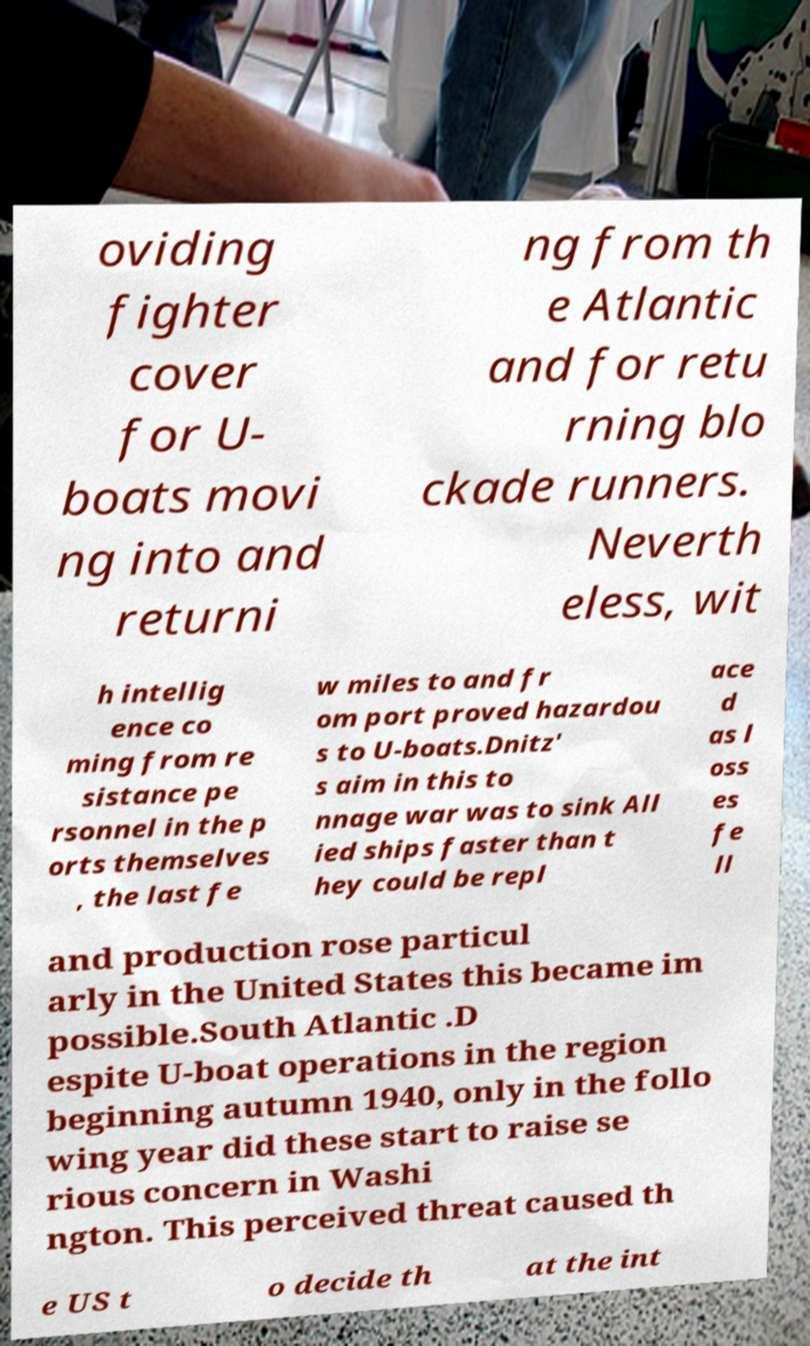Can you read and provide the text displayed in the image?This photo seems to have some interesting text. Can you extract and type it out for me? oviding fighter cover for U- boats movi ng into and returni ng from th e Atlantic and for retu rning blo ckade runners. Neverth eless, wit h intellig ence co ming from re sistance pe rsonnel in the p orts themselves , the last fe w miles to and fr om port proved hazardou s to U-boats.Dnitz' s aim in this to nnage war was to sink All ied ships faster than t hey could be repl ace d as l oss es fe ll and production rose particul arly in the United States this became im possible.South Atlantic .D espite U-boat operations in the region beginning autumn 1940, only in the follo wing year did these start to raise se rious concern in Washi ngton. This perceived threat caused th e US t o decide th at the int 